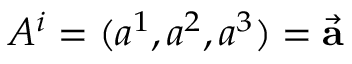Convert formula to latex. <formula><loc_0><loc_0><loc_500><loc_500>A ^ { i } = ( a ^ { 1 } , a ^ { 2 } , a ^ { 3 } ) = { \vec { a } }</formula> 